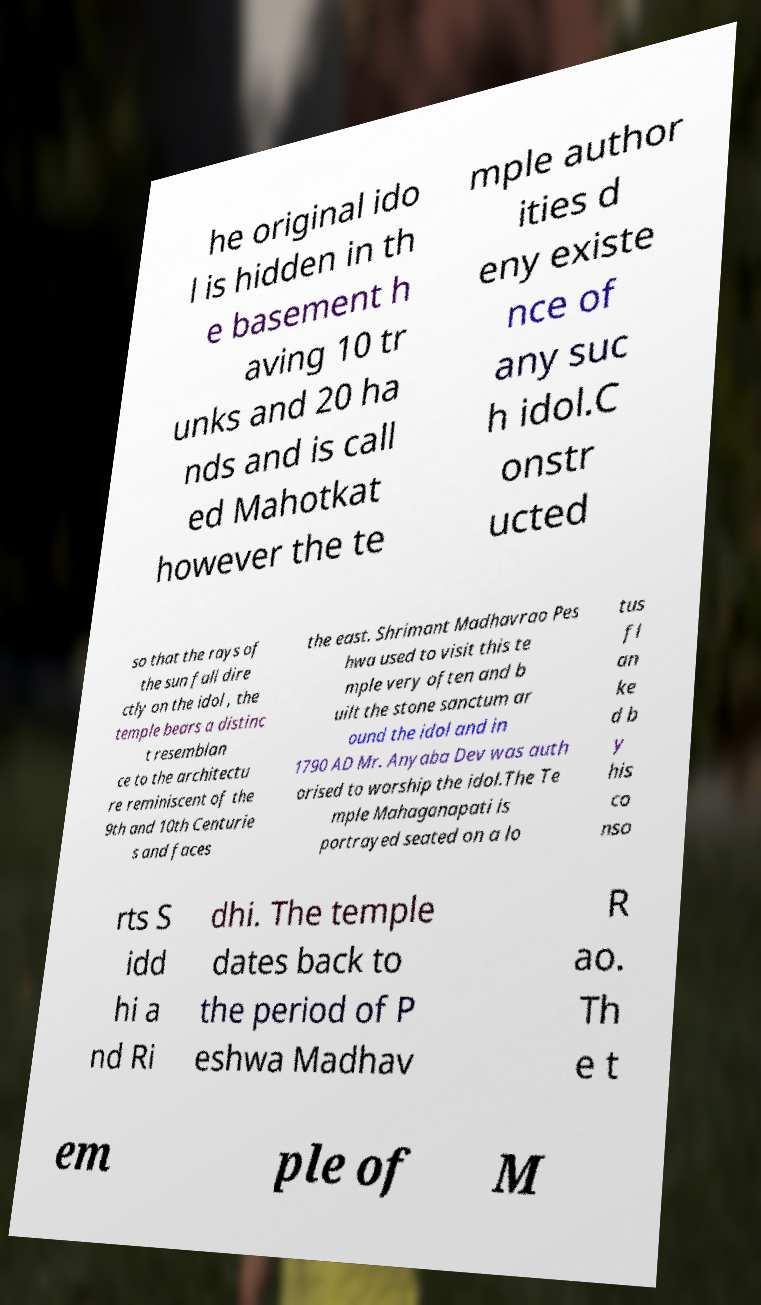Please identify and transcribe the text found in this image. he original ido l is hidden in th e basement h aving 10 tr unks and 20 ha nds and is call ed Mahotkat however the te mple author ities d eny existe nce of any suc h idol.C onstr ucted so that the rays of the sun fall dire ctly on the idol , the temple bears a distinc t resemblan ce to the architectu re reminiscent of the 9th and 10th Centurie s and faces the east. Shrimant Madhavrao Pes hwa used to visit this te mple very often and b uilt the stone sanctum ar ound the idol and in 1790 AD Mr. Anyaba Dev was auth orised to worship the idol.The Te mple Mahaganapati is portrayed seated on a lo tus fl an ke d b y his co nso rts S idd hi a nd Ri dhi. The temple dates back to the period of P eshwa Madhav R ao. Th e t em ple of M 